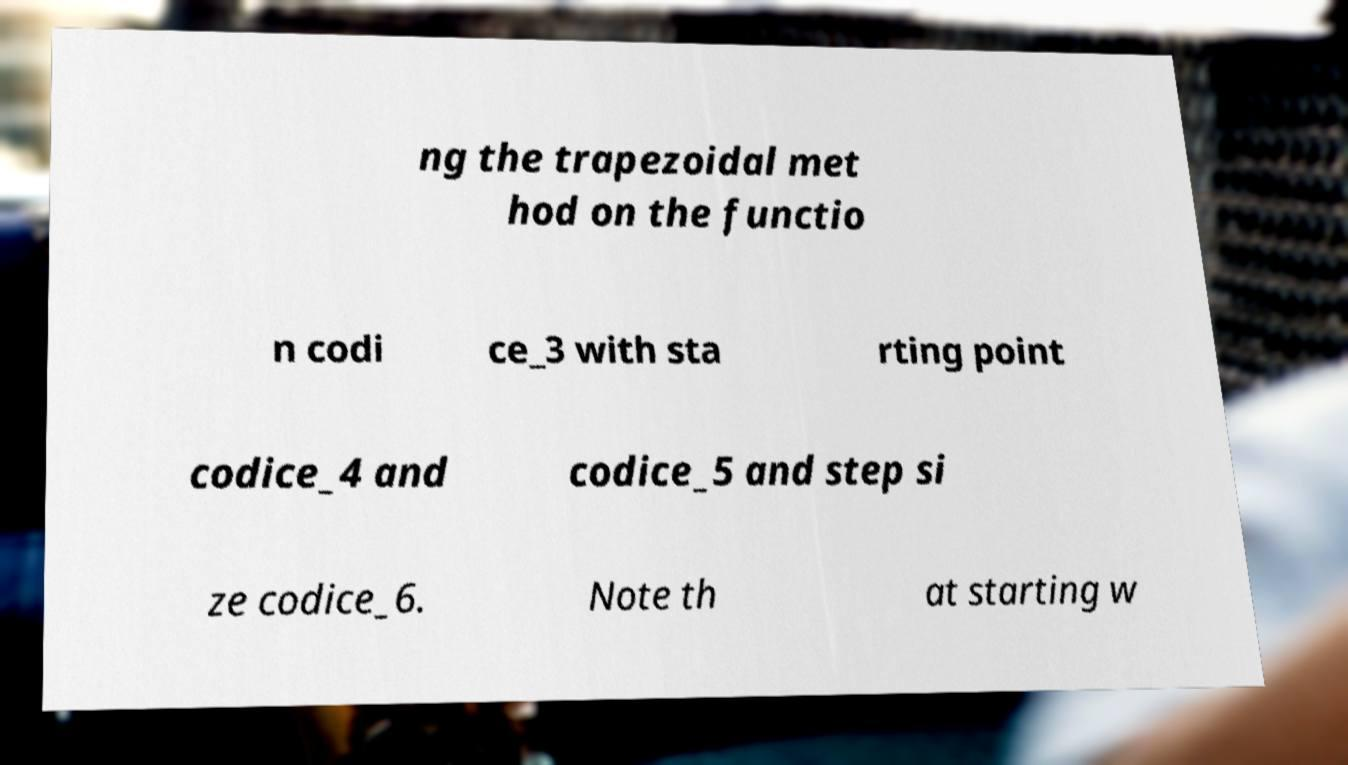What messages or text are displayed in this image? I need them in a readable, typed format. ng the trapezoidal met hod on the functio n codi ce_3 with sta rting point codice_4 and codice_5 and step si ze codice_6. Note th at starting w 